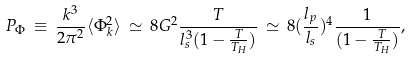Convert formula to latex. <formula><loc_0><loc_0><loc_500><loc_500>P _ { \Phi } \, \equiv \, \frac { k ^ { 3 } } { 2 \pi ^ { 2 } } \langle \Phi _ { k } ^ { 2 } \rangle \, \simeq \, 8 G ^ { 2 } \frac { T } { l _ { s } ^ { 3 } ( 1 - \frac { T } { T _ { H } } ) } \, \simeq \, 8 ( \frac { l _ { p } } { l _ { s } } ) ^ { 4 } \frac { 1 } { ( 1 - \frac { T } { T _ { H } } ) } ,</formula> 